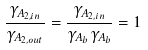<formula> <loc_0><loc_0><loc_500><loc_500>\frac { \gamma _ { A _ { 2 , i n } } } { \gamma _ { A _ { 2 , o u t } } } = \frac { \gamma _ { A _ { 2 , i n } } } { \gamma _ { A _ { b } } \gamma _ { A _ { b } } } = 1</formula> 